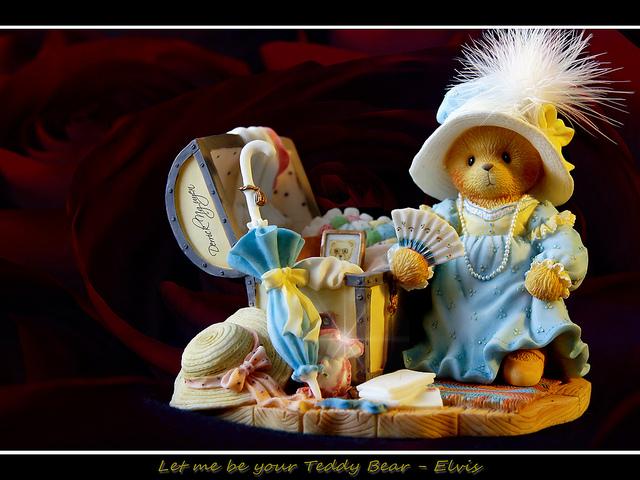Is the quote at the bottom something the bear would say?
Short answer required. Yes. Is this a decorative item?
Keep it brief. Yes. What type of animal is this?
Concise answer only. Bear. 